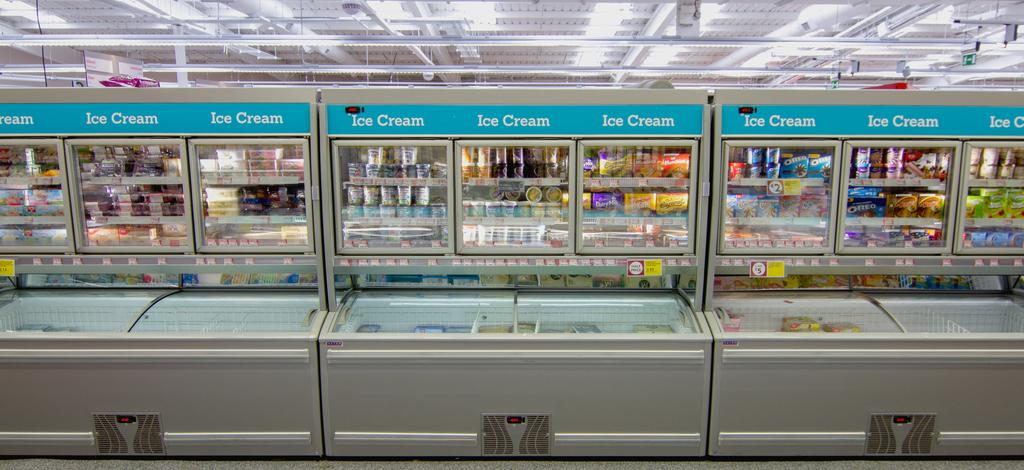Provide a one-sentence caption for the provided image. The freezer department of a store full of different ice cream options. 